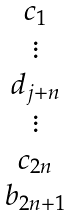<formula> <loc_0><loc_0><loc_500><loc_500>\begin{matrix} c _ { 1 } \\ \vdots \\ d _ { j + n } \\ \vdots \\ c _ { 2 n } \\ b _ { 2 n + 1 } \end{matrix}</formula> 